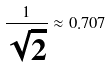Convert formula to latex. <formula><loc_0><loc_0><loc_500><loc_500>\frac { 1 } { \sqrt { 2 } } \approx 0 . 7 0 7</formula> 